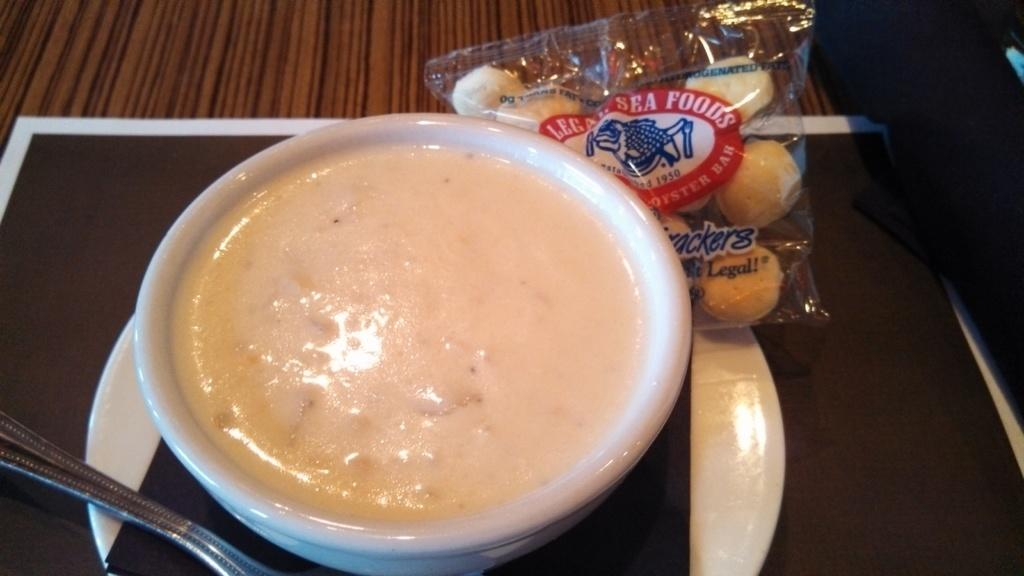What is in the bowl that is visible in the image? There is a bowl with a food item in the image. What else with food items can be seen in the image? There is a packet with food items in the image. What utensil is visible in the image? A spoon is visible in the image. What type of surface is present in the image? The wooden surface is present in the image. What color is the list of items in the image? There is no list of items present in the image, so it is not possible to determine its color. 